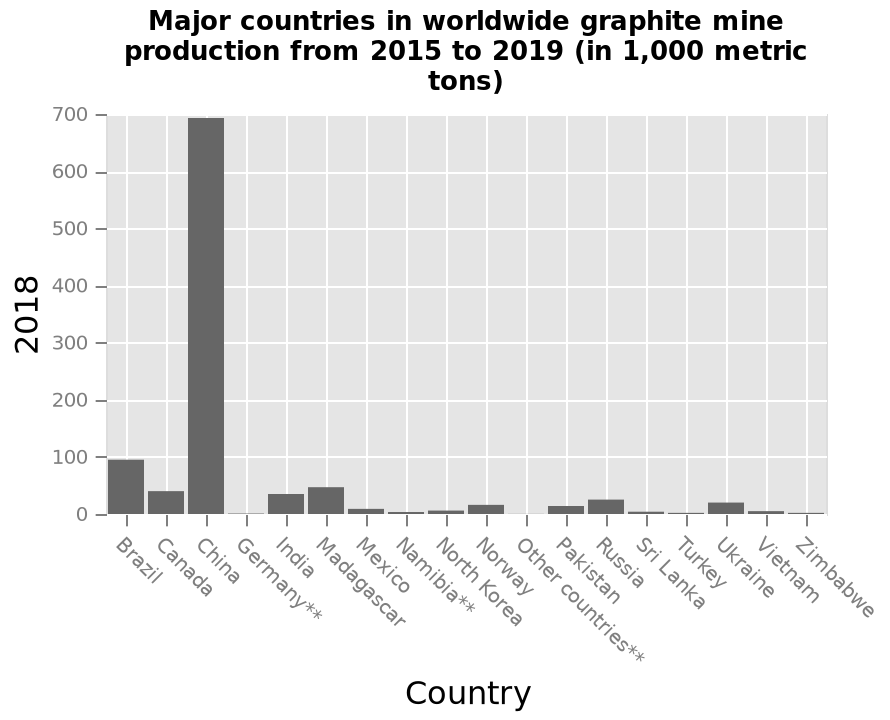<image>
How many countries produced less than 100,000 metric tons of graphite? All other countries each produced less than 100,000 metric tons of graphite. 